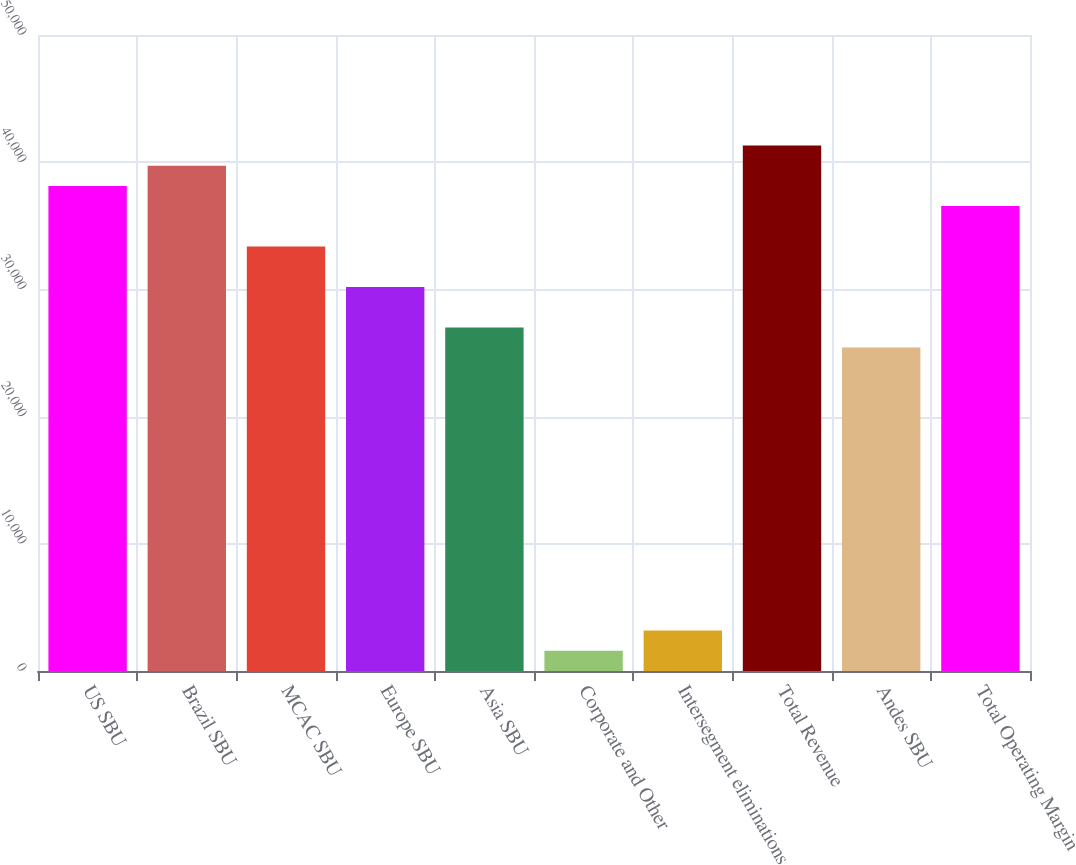Convert chart to OTSL. <chart><loc_0><loc_0><loc_500><loc_500><bar_chart><fcel>US SBU<fcel>Brazil SBU<fcel>MCAC SBU<fcel>Europe SBU<fcel>Asia SBU<fcel>Corporate and Other<fcel>Intersegment eliminations<fcel>Total Revenue<fcel>Andes SBU<fcel>Total Operating Margin<nl><fcel>38138.1<fcel>39727.2<fcel>33370.8<fcel>30192.7<fcel>27014.5<fcel>1589.25<fcel>3178.33<fcel>41316.2<fcel>25425.5<fcel>36549<nl></chart> 